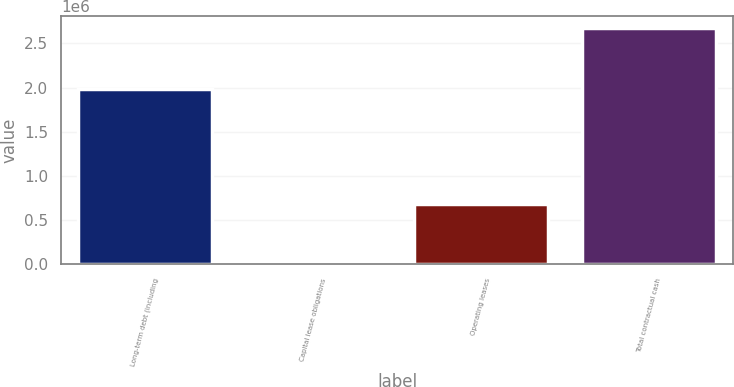Convert chart to OTSL. <chart><loc_0><loc_0><loc_500><loc_500><bar_chart><fcel>Long-term debt (including<fcel>Capital lease obligations<fcel>Operating leases<fcel>Total contractual cash<nl><fcel>1.98258e+06<fcel>7435<fcel>680816<fcel>2.67949e+06<nl></chart> 